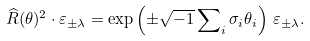<formula> <loc_0><loc_0><loc_500><loc_500>\widehat { R } ( \theta ) ^ { 2 } \cdot \varepsilon _ { \pm \lambda } = \exp \left ( \pm \sqrt { - 1 } \sum \nolimits _ { i } \sigma _ { i } \theta _ { i } \right ) \, \varepsilon _ { \pm \lambda } .</formula> 